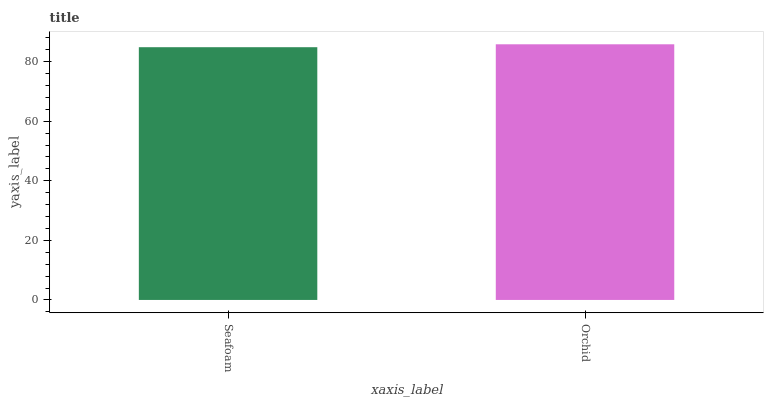Is Orchid the minimum?
Answer yes or no. No. Is Orchid greater than Seafoam?
Answer yes or no. Yes. Is Seafoam less than Orchid?
Answer yes or no. Yes. Is Seafoam greater than Orchid?
Answer yes or no. No. Is Orchid less than Seafoam?
Answer yes or no. No. Is Orchid the high median?
Answer yes or no. Yes. Is Seafoam the low median?
Answer yes or no. Yes. Is Seafoam the high median?
Answer yes or no. No. Is Orchid the low median?
Answer yes or no. No. 